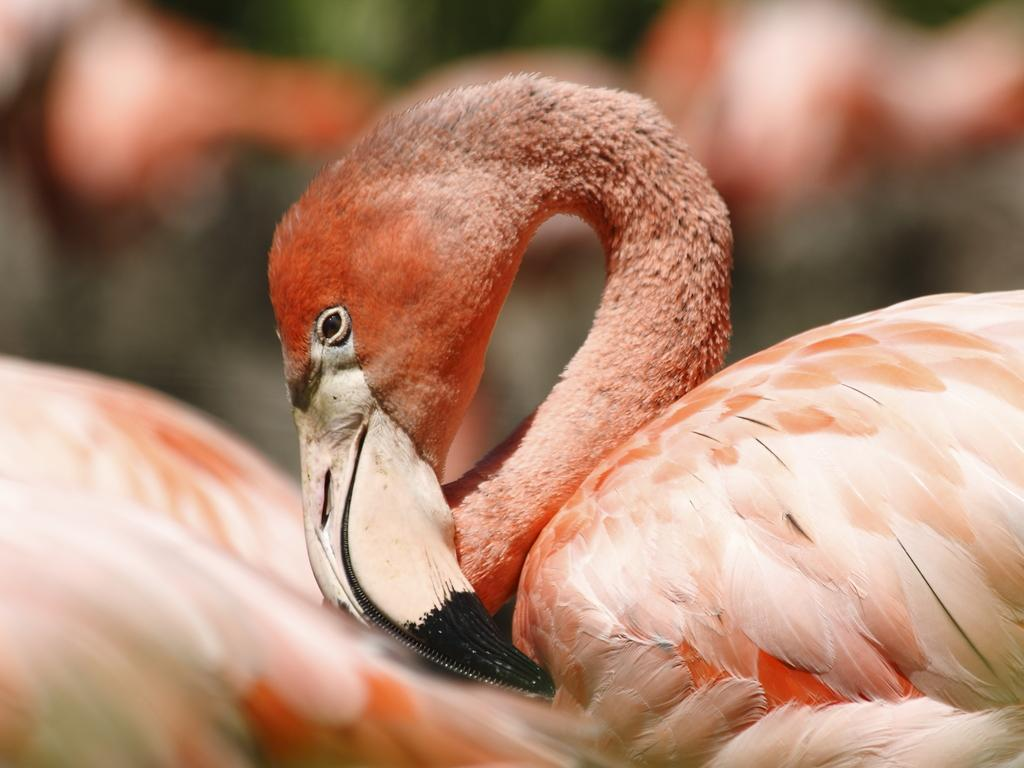What is the main subject of the image? The main subject of the image is a bird. Where is the bird located in the image? The bird is in the middle of the image. Can you describe the background of the image? The background of the image is blurred. What type of tax does the bird have to pay in the image? There is no reference to taxes or any financial transactions in the image, so it's not possible to determine what type of tax the bird might have to pay. 